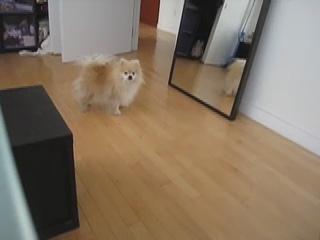How many dogs?
Give a very brief answer. 1. 